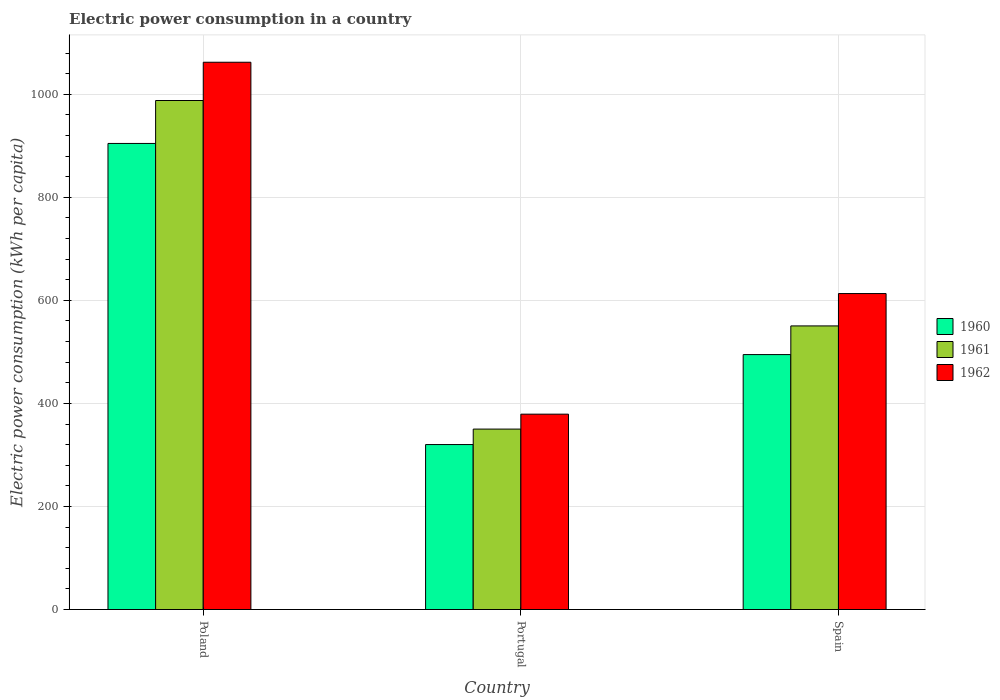Are the number of bars on each tick of the X-axis equal?
Keep it short and to the point. Yes. What is the label of the 2nd group of bars from the left?
Your response must be concise. Portugal. In how many cases, is the number of bars for a given country not equal to the number of legend labels?
Keep it short and to the point. 0. What is the electric power consumption in in 1960 in Portugal?
Ensure brevity in your answer.  320.17. Across all countries, what is the maximum electric power consumption in in 1961?
Offer a terse response. 987.92. Across all countries, what is the minimum electric power consumption in in 1962?
Keep it short and to the point. 379.14. In which country was the electric power consumption in in 1962 maximum?
Provide a short and direct response. Poland. In which country was the electric power consumption in in 1961 minimum?
Ensure brevity in your answer.  Portugal. What is the total electric power consumption in in 1961 in the graph?
Offer a terse response. 1888.55. What is the difference between the electric power consumption in in 1960 in Portugal and that in Spain?
Your response must be concise. -174.62. What is the difference between the electric power consumption in in 1962 in Portugal and the electric power consumption in in 1961 in Spain?
Give a very brief answer. -171.29. What is the average electric power consumption in in 1962 per country?
Offer a very short reply. 684.86. What is the difference between the electric power consumption in of/in 1962 and electric power consumption in of/in 1961 in Portugal?
Your answer should be compact. 28.95. In how many countries, is the electric power consumption in in 1962 greater than 520 kWh per capita?
Ensure brevity in your answer.  2. What is the ratio of the electric power consumption in in 1962 in Poland to that in Portugal?
Ensure brevity in your answer.  2.8. Is the electric power consumption in in 1961 in Poland less than that in Spain?
Keep it short and to the point. No. What is the difference between the highest and the second highest electric power consumption in in 1962?
Offer a terse response. -234.11. What is the difference between the highest and the lowest electric power consumption in in 1961?
Offer a terse response. 637.72. In how many countries, is the electric power consumption in in 1960 greater than the average electric power consumption in in 1960 taken over all countries?
Ensure brevity in your answer.  1. Is the sum of the electric power consumption in in 1960 in Portugal and Spain greater than the maximum electric power consumption in in 1961 across all countries?
Give a very brief answer. No. What does the 1st bar from the left in Spain represents?
Offer a very short reply. 1960. What does the 1st bar from the right in Portugal represents?
Offer a terse response. 1962. How many bars are there?
Your answer should be very brief. 9. Does the graph contain any zero values?
Your answer should be compact. No. Does the graph contain grids?
Your answer should be compact. Yes. What is the title of the graph?
Your answer should be compact. Electric power consumption in a country. Does "2007" appear as one of the legend labels in the graph?
Provide a short and direct response. No. What is the label or title of the Y-axis?
Make the answer very short. Electric power consumption (kWh per capita). What is the Electric power consumption (kWh per capita) of 1960 in Poland?
Offer a terse response. 904.57. What is the Electric power consumption (kWh per capita) of 1961 in Poland?
Your answer should be compact. 987.92. What is the Electric power consumption (kWh per capita) of 1962 in Poland?
Your response must be concise. 1062.18. What is the Electric power consumption (kWh per capita) in 1960 in Portugal?
Provide a short and direct response. 320.17. What is the Electric power consumption (kWh per capita) of 1961 in Portugal?
Your answer should be very brief. 350.19. What is the Electric power consumption (kWh per capita) of 1962 in Portugal?
Give a very brief answer. 379.14. What is the Electric power consumption (kWh per capita) in 1960 in Spain?
Provide a succinct answer. 494.8. What is the Electric power consumption (kWh per capita) of 1961 in Spain?
Offer a very short reply. 550.44. What is the Electric power consumption (kWh per capita) of 1962 in Spain?
Your answer should be compact. 613.25. Across all countries, what is the maximum Electric power consumption (kWh per capita) of 1960?
Your answer should be compact. 904.57. Across all countries, what is the maximum Electric power consumption (kWh per capita) in 1961?
Your answer should be very brief. 987.92. Across all countries, what is the maximum Electric power consumption (kWh per capita) of 1962?
Your answer should be very brief. 1062.18. Across all countries, what is the minimum Electric power consumption (kWh per capita) in 1960?
Your answer should be very brief. 320.17. Across all countries, what is the minimum Electric power consumption (kWh per capita) of 1961?
Ensure brevity in your answer.  350.19. Across all countries, what is the minimum Electric power consumption (kWh per capita) in 1962?
Keep it short and to the point. 379.14. What is the total Electric power consumption (kWh per capita) of 1960 in the graph?
Your answer should be compact. 1719.53. What is the total Electric power consumption (kWh per capita) in 1961 in the graph?
Give a very brief answer. 1888.55. What is the total Electric power consumption (kWh per capita) of 1962 in the graph?
Provide a short and direct response. 2054.57. What is the difference between the Electric power consumption (kWh per capita) in 1960 in Poland and that in Portugal?
Keep it short and to the point. 584.39. What is the difference between the Electric power consumption (kWh per capita) of 1961 in Poland and that in Portugal?
Your response must be concise. 637.72. What is the difference between the Electric power consumption (kWh per capita) of 1962 in Poland and that in Portugal?
Keep it short and to the point. 683.03. What is the difference between the Electric power consumption (kWh per capita) of 1960 in Poland and that in Spain?
Offer a terse response. 409.77. What is the difference between the Electric power consumption (kWh per capita) in 1961 in Poland and that in Spain?
Make the answer very short. 437.48. What is the difference between the Electric power consumption (kWh per capita) in 1962 in Poland and that in Spain?
Provide a succinct answer. 448.93. What is the difference between the Electric power consumption (kWh per capita) in 1960 in Portugal and that in Spain?
Keep it short and to the point. -174.62. What is the difference between the Electric power consumption (kWh per capita) in 1961 in Portugal and that in Spain?
Provide a succinct answer. -200.24. What is the difference between the Electric power consumption (kWh per capita) of 1962 in Portugal and that in Spain?
Give a very brief answer. -234.11. What is the difference between the Electric power consumption (kWh per capita) of 1960 in Poland and the Electric power consumption (kWh per capita) of 1961 in Portugal?
Provide a short and direct response. 554.37. What is the difference between the Electric power consumption (kWh per capita) in 1960 in Poland and the Electric power consumption (kWh per capita) in 1962 in Portugal?
Provide a succinct answer. 525.42. What is the difference between the Electric power consumption (kWh per capita) in 1961 in Poland and the Electric power consumption (kWh per capita) in 1962 in Portugal?
Make the answer very short. 608.78. What is the difference between the Electric power consumption (kWh per capita) of 1960 in Poland and the Electric power consumption (kWh per capita) of 1961 in Spain?
Keep it short and to the point. 354.13. What is the difference between the Electric power consumption (kWh per capita) of 1960 in Poland and the Electric power consumption (kWh per capita) of 1962 in Spain?
Ensure brevity in your answer.  291.32. What is the difference between the Electric power consumption (kWh per capita) of 1961 in Poland and the Electric power consumption (kWh per capita) of 1962 in Spain?
Your answer should be very brief. 374.67. What is the difference between the Electric power consumption (kWh per capita) in 1960 in Portugal and the Electric power consumption (kWh per capita) in 1961 in Spain?
Your response must be concise. -230.26. What is the difference between the Electric power consumption (kWh per capita) in 1960 in Portugal and the Electric power consumption (kWh per capita) in 1962 in Spain?
Make the answer very short. -293.07. What is the difference between the Electric power consumption (kWh per capita) of 1961 in Portugal and the Electric power consumption (kWh per capita) of 1962 in Spain?
Offer a very short reply. -263.05. What is the average Electric power consumption (kWh per capita) in 1960 per country?
Ensure brevity in your answer.  573.18. What is the average Electric power consumption (kWh per capita) in 1961 per country?
Provide a succinct answer. 629.52. What is the average Electric power consumption (kWh per capita) of 1962 per country?
Provide a succinct answer. 684.86. What is the difference between the Electric power consumption (kWh per capita) in 1960 and Electric power consumption (kWh per capita) in 1961 in Poland?
Your answer should be compact. -83.35. What is the difference between the Electric power consumption (kWh per capita) in 1960 and Electric power consumption (kWh per capita) in 1962 in Poland?
Offer a terse response. -157.61. What is the difference between the Electric power consumption (kWh per capita) of 1961 and Electric power consumption (kWh per capita) of 1962 in Poland?
Provide a succinct answer. -74.26. What is the difference between the Electric power consumption (kWh per capita) of 1960 and Electric power consumption (kWh per capita) of 1961 in Portugal?
Provide a short and direct response. -30.02. What is the difference between the Electric power consumption (kWh per capita) of 1960 and Electric power consumption (kWh per capita) of 1962 in Portugal?
Provide a short and direct response. -58.97. What is the difference between the Electric power consumption (kWh per capita) of 1961 and Electric power consumption (kWh per capita) of 1962 in Portugal?
Your answer should be compact. -28.95. What is the difference between the Electric power consumption (kWh per capita) of 1960 and Electric power consumption (kWh per capita) of 1961 in Spain?
Ensure brevity in your answer.  -55.64. What is the difference between the Electric power consumption (kWh per capita) of 1960 and Electric power consumption (kWh per capita) of 1962 in Spain?
Give a very brief answer. -118.45. What is the difference between the Electric power consumption (kWh per capita) in 1961 and Electric power consumption (kWh per capita) in 1962 in Spain?
Your answer should be compact. -62.81. What is the ratio of the Electric power consumption (kWh per capita) in 1960 in Poland to that in Portugal?
Offer a terse response. 2.83. What is the ratio of the Electric power consumption (kWh per capita) of 1961 in Poland to that in Portugal?
Keep it short and to the point. 2.82. What is the ratio of the Electric power consumption (kWh per capita) of 1962 in Poland to that in Portugal?
Make the answer very short. 2.8. What is the ratio of the Electric power consumption (kWh per capita) in 1960 in Poland to that in Spain?
Your answer should be very brief. 1.83. What is the ratio of the Electric power consumption (kWh per capita) of 1961 in Poland to that in Spain?
Your answer should be compact. 1.79. What is the ratio of the Electric power consumption (kWh per capita) of 1962 in Poland to that in Spain?
Keep it short and to the point. 1.73. What is the ratio of the Electric power consumption (kWh per capita) in 1960 in Portugal to that in Spain?
Offer a very short reply. 0.65. What is the ratio of the Electric power consumption (kWh per capita) in 1961 in Portugal to that in Spain?
Your answer should be very brief. 0.64. What is the ratio of the Electric power consumption (kWh per capita) of 1962 in Portugal to that in Spain?
Your response must be concise. 0.62. What is the difference between the highest and the second highest Electric power consumption (kWh per capita) in 1960?
Your answer should be very brief. 409.77. What is the difference between the highest and the second highest Electric power consumption (kWh per capita) in 1961?
Make the answer very short. 437.48. What is the difference between the highest and the second highest Electric power consumption (kWh per capita) in 1962?
Ensure brevity in your answer.  448.93. What is the difference between the highest and the lowest Electric power consumption (kWh per capita) in 1960?
Offer a terse response. 584.39. What is the difference between the highest and the lowest Electric power consumption (kWh per capita) of 1961?
Provide a short and direct response. 637.72. What is the difference between the highest and the lowest Electric power consumption (kWh per capita) in 1962?
Give a very brief answer. 683.03. 